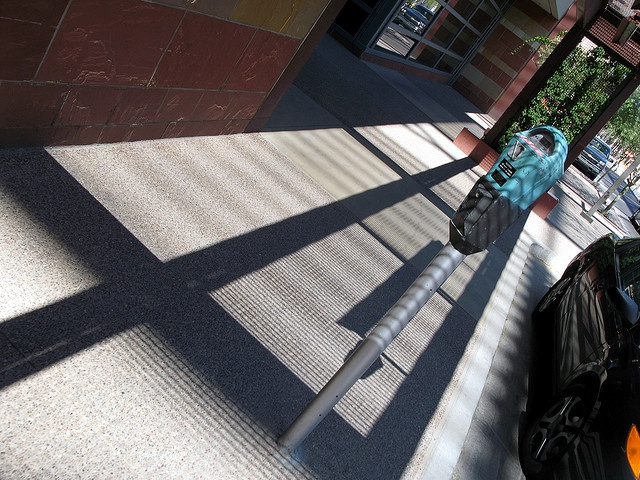Describe the objects in this image and their specific colors. I can see car in black, gray, red, and maroon tones, parking meter in black, teal, and gray tones, and truck in black, gray, and blue tones in this image. 